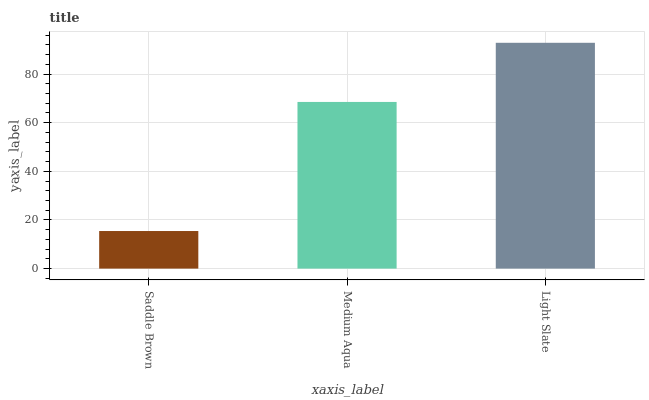Is Saddle Brown the minimum?
Answer yes or no. Yes. Is Light Slate the maximum?
Answer yes or no. Yes. Is Medium Aqua the minimum?
Answer yes or no. No. Is Medium Aqua the maximum?
Answer yes or no. No. Is Medium Aqua greater than Saddle Brown?
Answer yes or no. Yes. Is Saddle Brown less than Medium Aqua?
Answer yes or no. Yes. Is Saddle Brown greater than Medium Aqua?
Answer yes or no. No. Is Medium Aqua less than Saddle Brown?
Answer yes or no. No. Is Medium Aqua the high median?
Answer yes or no. Yes. Is Medium Aqua the low median?
Answer yes or no. Yes. Is Saddle Brown the high median?
Answer yes or no. No. Is Light Slate the low median?
Answer yes or no. No. 